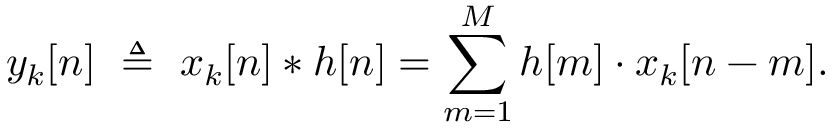Convert formula to latex. <formula><loc_0><loc_0><loc_500><loc_500>y _ { k } [ n ] \ \triangle q \ x _ { k } [ n ] * h [ n ] = \sum _ { m = 1 } ^ { M } h [ m ] \cdot x _ { k } [ n - m ] .</formula> 